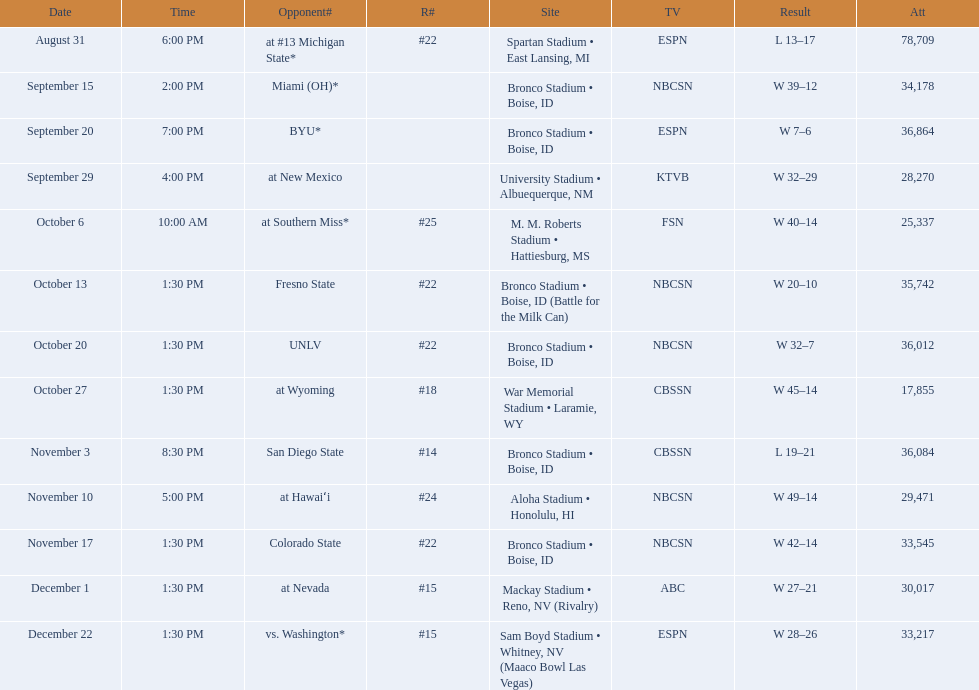What are the opponent teams of the 2012 boise state broncos football team? At #13 michigan state*, miami (oh)*, byu*, at new mexico, at southern miss*, fresno state, unlv, at wyoming, san diego state, at hawaiʻi, colorado state, at nevada, vs. washington*. How has the highest rank of these opponents? San Diego State. 